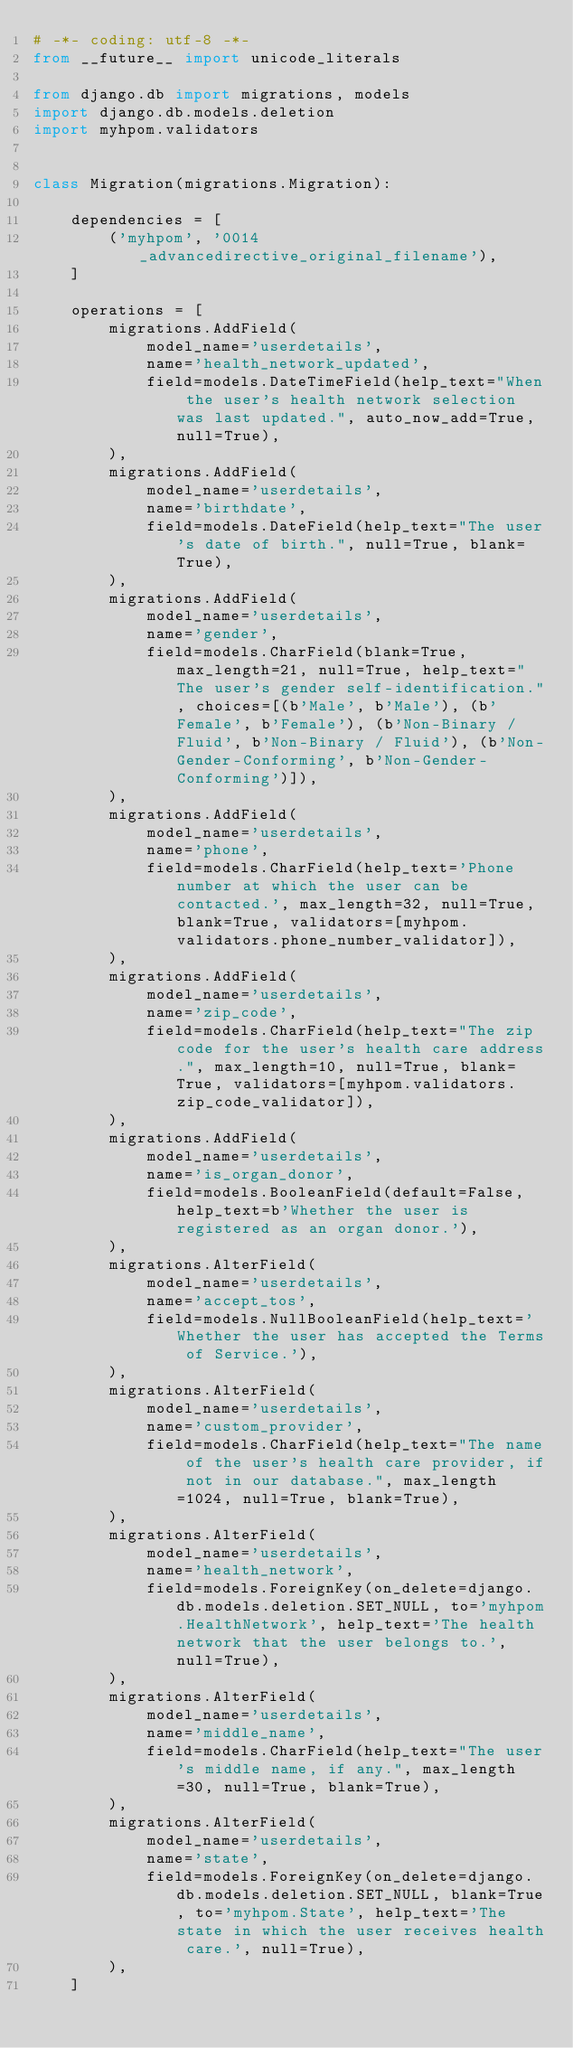Convert code to text. <code><loc_0><loc_0><loc_500><loc_500><_Python_># -*- coding: utf-8 -*-
from __future__ import unicode_literals

from django.db import migrations, models
import django.db.models.deletion
import myhpom.validators


class Migration(migrations.Migration):

    dependencies = [
        ('myhpom', '0014_advancedirective_original_filename'),
    ]

    operations = [
        migrations.AddField(
            model_name='userdetails',
            name='health_network_updated',
            field=models.DateTimeField(help_text="When the user's health network selection was last updated.", auto_now_add=True, null=True),
        ),
        migrations.AddField(
            model_name='userdetails',
            name='birthdate',
            field=models.DateField(help_text="The user's date of birth.", null=True, blank=True),
        ),
        migrations.AddField(
            model_name='userdetails',
            name='gender',
            field=models.CharField(blank=True, max_length=21, null=True, help_text="The user's gender self-identification.", choices=[(b'Male', b'Male'), (b'Female', b'Female'), (b'Non-Binary / Fluid', b'Non-Binary / Fluid'), (b'Non-Gender-Conforming', b'Non-Gender-Conforming')]),
        ),
        migrations.AddField(
            model_name='userdetails',
            name='phone',
            field=models.CharField(help_text='Phone number at which the user can be contacted.', max_length=32, null=True, blank=True, validators=[myhpom.validators.phone_number_validator]),
        ),
        migrations.AddField(
            model_name='userdetails',
            name='zip_code',
            field=models.CharField(help_text="The zip code for the user's health care address.", max_length=10, null=True, blank=True, validators=[myhpom.validators.zip_code_validator]),
        ),
        migrations.AddField(
            model_name='userdetails',
            name='is_organ_donor',
            field=models.BooleanField(default=False, help_text=b'Whether the user is registered as an organ donor.'),
        ),
        migrations.AlterField(
            model_name='userdetails',
            name='accept_tos',
            field=models.NullBooleanField(help_text='Whether the user has accepted the Terms of Service.'),
        ),
        migrations.AlterField(
            model_name='userdetails',
            name='custom_provider',
            field=models.CharField(help_text="The name of the user's health care provider, if not in our database.", max_length=1024, null=True, blank=True),
        ),
        migrations.AlterField(
            model_name='userdetails',
            name='health_network',
            field=models.ForeignKey(on_delete=django.db.models.deletion.SET_NULL, to='myhpom.HealthNetwork', help_text='The health network that the user belongs to.', null=True),
        ),
        migrations.AlterField(
            model_name='userdetails',
            name='middle_name',
            field=models.CharField(help_text="The user's middle name, if any.", max_length=30, null=True, blank=True),
        ),
        migrations.AlterField(
            model_name='userdetails',
            name='state',
            field=models.ForeignKey(on_delete=django.db.models.deletion.SET_NULL, blank=True, to='myhpom.State', help_text='The state in which the user receives health care.', null=True),
        ),
    ]
</code> 